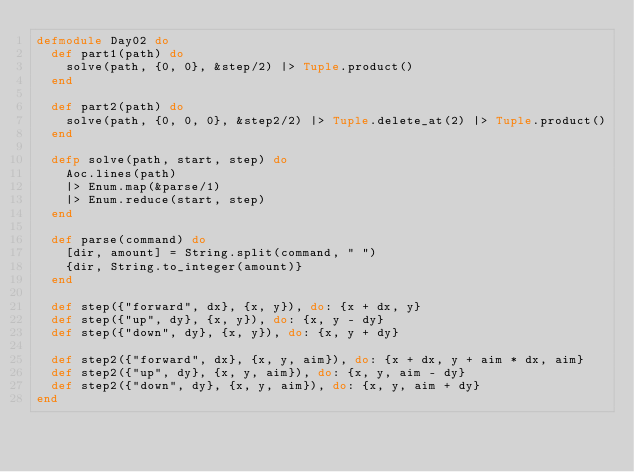<code> <loc_0><loc_0><loc_500><loc_500><_Elixir_>defmodule Day02 do
  def part1(path) do
    solve(path, {0, 0}, &step/2) |> Tuple.product()
  end

  def part2(path) do
    solve(path, {0, 0, 0}, &step2/2) |> Tuple.delete_at(2) |> Tuple.product()
  end

  defp solve(path, start, step) do
    Aoc.lines(path)
    |> Enum.map(&parse/1)
    |> Enum.reduce(start, step)
  end

  def parse(command) do
    [dir, amount] = String.split(command, " ")
    {dir, String.to_integer(amount)}
  end

  def step({"forward", dx}, {x, y}), do: {x + dx, y}
  def step({"up", dy}, {x, y}), do: {x, y - dy}
  def step({"down", dy}, {x, y}), do: {x, y + dy}

  def step2({"forward", dx}, {x, y, aim}), do: {x + dx, y + aim * dx, aim}
  def step2({"up", dy}, {x, y, aim}), do: {x, y, aim - dy}
  def step2({"down", dy}, {x, y, aim}), do: {x, y, aim + dy}
end
</code> 